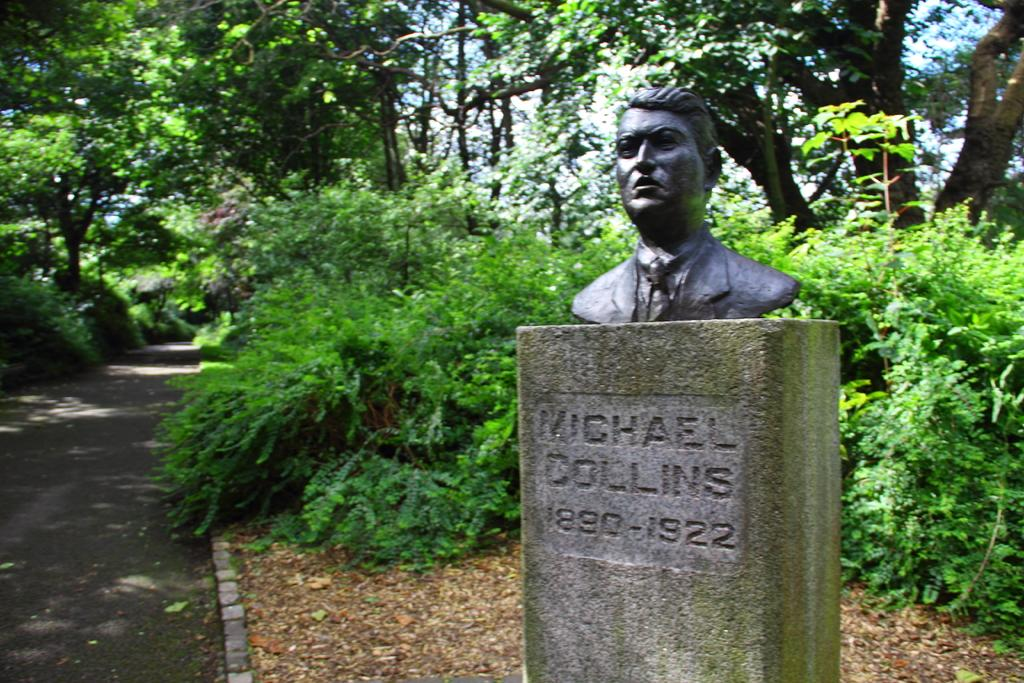What is the main subject on the pillar in the image? There is a sculpture on a pillar in the image. What else can be seen on the pillar besides the sculpture? There is text and numerical numbers on the pillar. What can be seen in the background of the image? There are trees, plants, and a road visible in the background of the image. What type of crime is being committed by the ant in the image? There is no ant present in the image, and therefore no crime can be committed by an ant. Where is the scarecrow located in the image? There is no scarecrow present in the image. 